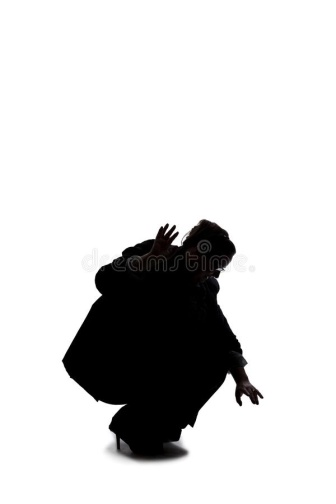Can you tell a story about the person's situation in the image? In a far-off future, amidst a world dominated by stark contrasts and minimalistic landscapes, lived a solitary individual known as The Seeker. Cloaked in the shadows of twilight, The Seeker was on a relentless quest to uncover fragments of forgotten truths. On this particular day, they found themselves in an ancient, abandoned arena. Though the arena now stood silent and whitewashed by time, it once roared with the passion of warriors and guardians who fought valiantly to protect their world. Crouching low, with arms poised and fingers extended like claws, The Seeker sensed a disturbance in the still air. Their sharp instincts told them that they were on the cusp of discovering a pivotal relic, a key to unlock the secrets of their ancestors. The stark white surroundings magnified their every movement, emphasizing the critical nature of their mission. In this silent expanse, The Seeker's silhouette stood out boldly, embodying the courage and determination needed to unveil the mysteries that would rebuild their fractured world. 